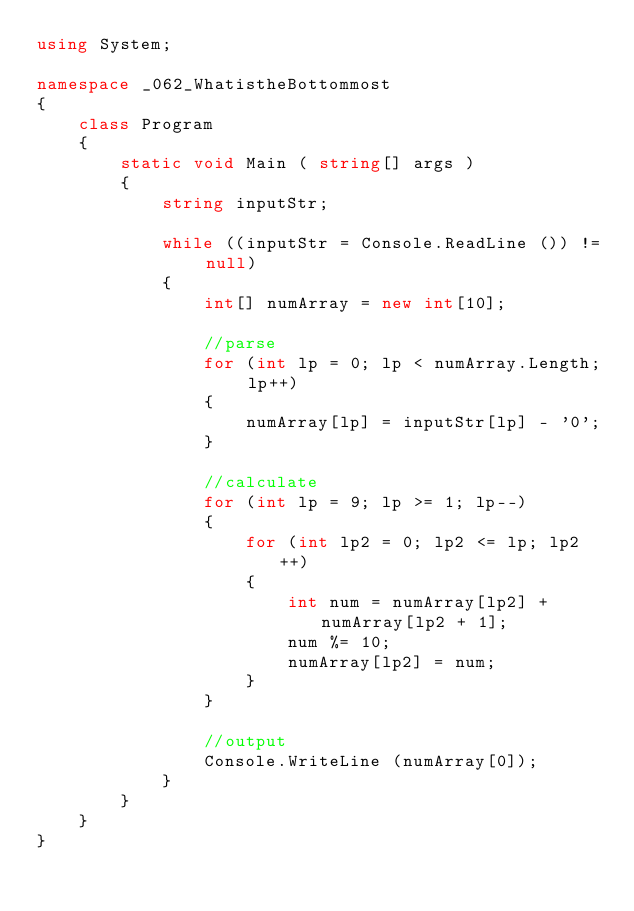<code> <loc_0><loc_0><loc_500><loc_500><_C#_>using System;

namespace _062_WhatistheBottommost
{
	class Program
	{
		static void Main ( string[] args )
		{
			string inputStr;

			while ((inputStr = Console.ReadLine ()) != null)
			{
				int[] numArray = new int[10];

				//parse
				for (int lp = 0; lp < numArray.Length; lp++)
				{
					numArray[lp] = inputStr[lp] - '0';
				}

				//calculate
				for (int lp = 9; lp >= 1; lp--)
				{
					for (int lp2 = 0; lp2 <= lp; lp2++)
					{
						int num = numArray[lp2] + numArray[lp2 + 1];
						num %= 10;
						numArray[lp2] = num;
					}
				}

				//output
				Console.WriteLine (numArray[0]);
			}
		}
	}
}</code> 